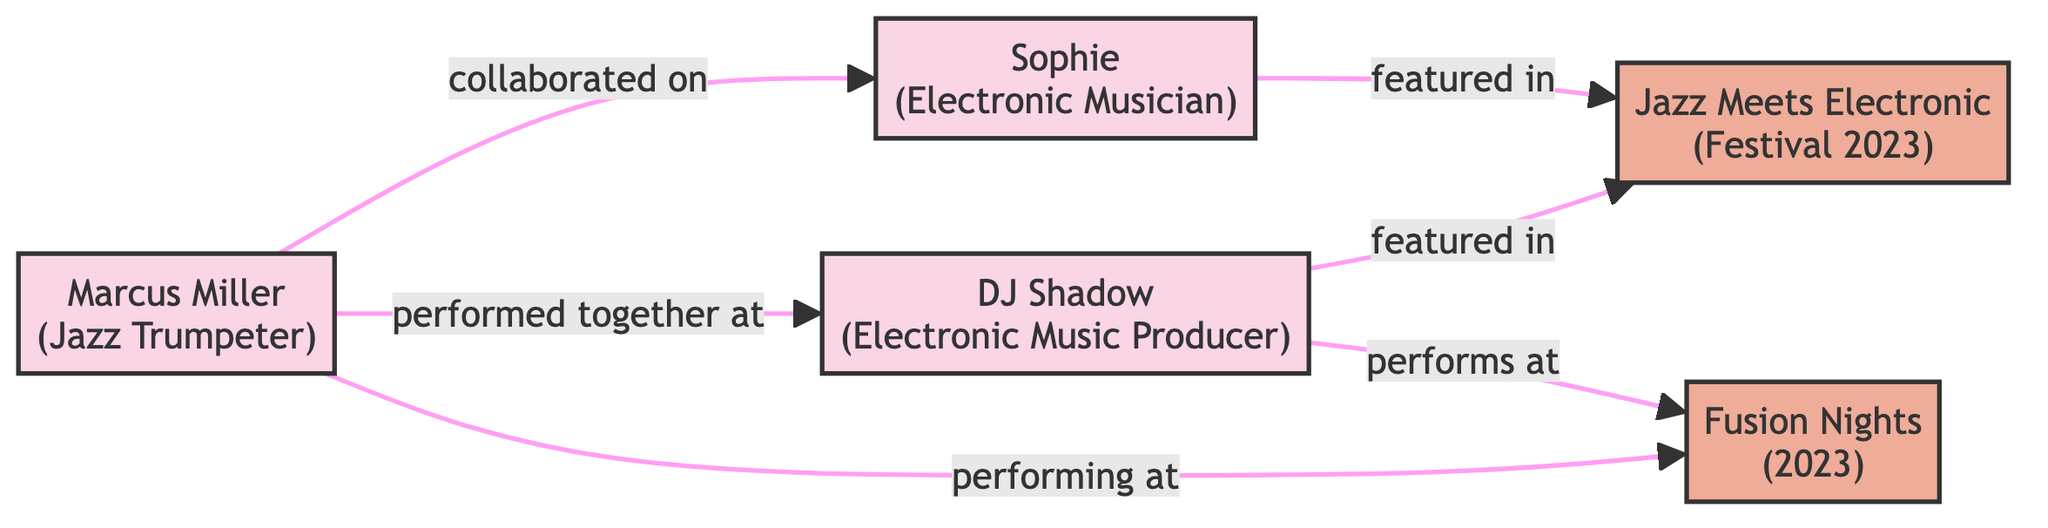What is the total number of musicians in the diagram? In the diagram, there are three distinct musicians: Marcus Miller (Jazz Trumpeter), DJ Shadow (Electronic Music Producer), and Sophie (Electronic Musician). Counting these, the total number is three.
Answer: 3 Who performed together with Marcus Miller? The edge labeled "performed together at" connects Marcus Miller to DJ Shadow, indicating that they have performed together. Therefore, the answer is DJ Shadow.
Answer: DJ Shadow How many events are featured in the diagram? There are two events represented in the diagram: "Jazz Meets Electronic (Festival 2023)" and "Fusion Nights (2023)". By counting these, we find that there are two events in total.
Answer: 2 Which event features both DJ Shadow and Sophie? The edge connecting DJ Shadow and Sophie to the event "Jazz Meets Electronic (Festival 2023)" indicates that both are featured in this event. Thus, the answer is "Jazz Meets Electronic (Festival 2023)".
Answer: Jazz Meets Electronic (Festival 2023) How many collaborations involve the jazz trumpeter? In the diagram, Marcus Miller (the jazz trumpeter) is involved in two types of interactions: He has performed together with DJ Shadow and collaborated with Sophie. Counting these connections, there are two collaborations.
Answer: 2 Which musician is associated with both events in the diagram? The edges illustrate that Marcus Miller is described as performing at "Fusion Nights (2023)" and is also connected to "Jazz Meets Electronic (Festival 2023)" through his collaboration with DJ Shadow and Sophie. Thus, the musician associated with both is Marcus Miller.
Answer: Marcus Miller Which musician has collaborated with Sophie? According to the diagram, Marcus Miller has a direct edge labeled "collaborated on" leading to Sophie. This means that he has collaborated with her.
Answer: Marcus Miller What type of musical event is "Fusion Nights (2023)"? The event "Fusion Nights (2023)" is classified as a fusion event that features collaborations between different musicians; specifically, it includes performances by Marcus Miller and DJ Shadow. Thus, the type of event is a fusion event.
Answer: Fusion event 